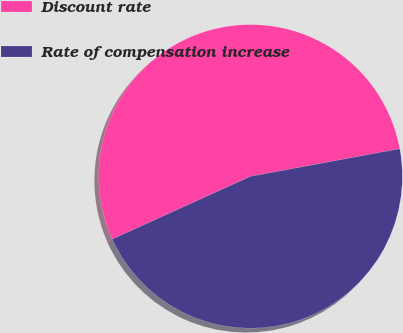<chart> <loc_0><loc_0><loc_500><loc_500><pie_chart><fcel>Discount rate<fcel>Rate of compensation increase<nl><fcel>53.87%<fcel>46.13%<nl></chart> 